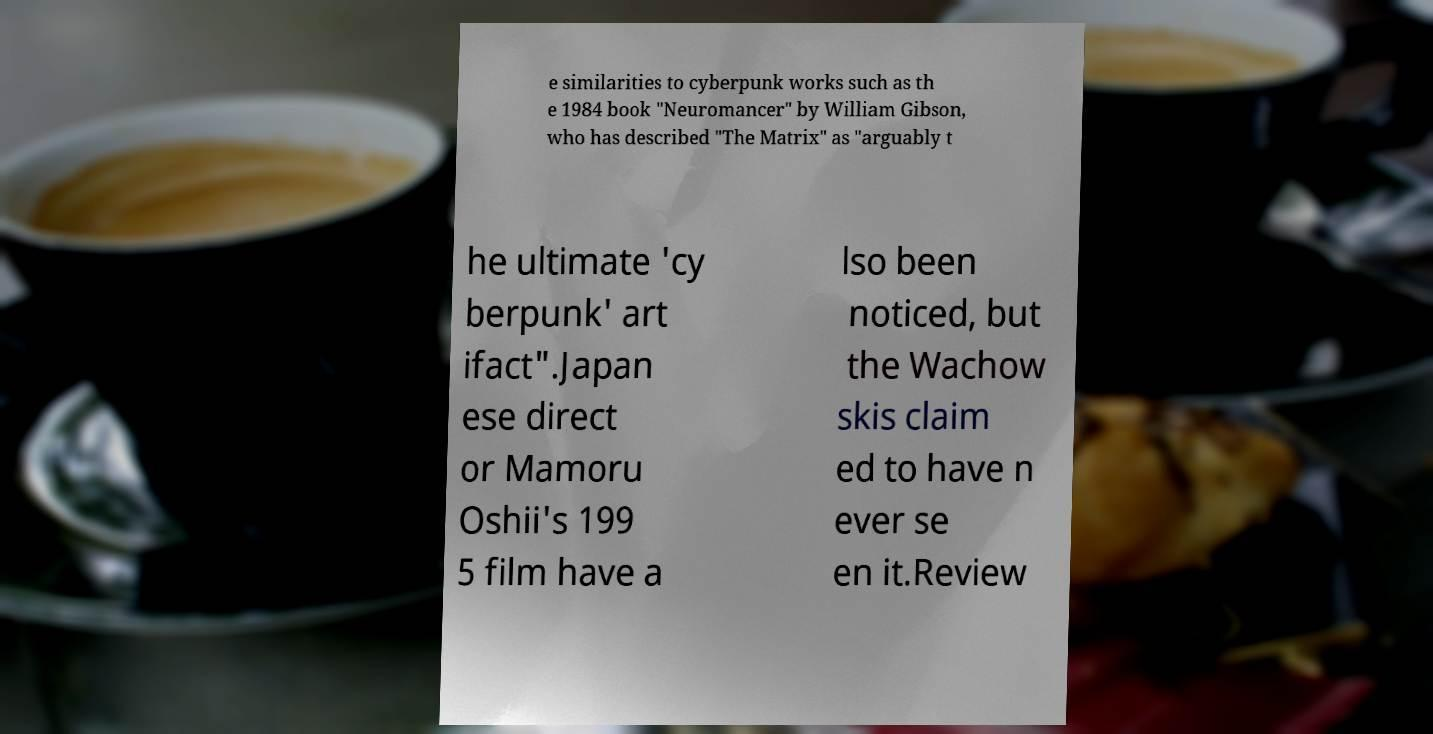What messages or text are displayed in this image? I need them in a readable, typed format. e similarities to cyberpunk works such as th e 1984 book "Neuromancer" by William Gibson, who has described "The Matrix" as "arguably t he ultimate 'cy berpunk' art ifact".Japan ese direct or Mamoru Oshii's 199 5 film have a lso been noticed, but the Wachow skis claim ed to have n ever se en it.Review 